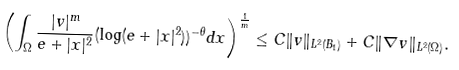<formula> <loc_0><loc_0><loc_500><loc_500>\left ( \int _ { \Omega } \frac { | v | ^ { m } } { e + | x | ^ { 2 } } ( \log ( e + | x | ^ { 2 } ) ) ^ { - \theta } d x \right ) ^ { \frac { 1 } { m } } \leq C \| v \| _ { L ^ { 2 } ( B _ { 1 } ) } + C \| \nabla v \| _ { L ^ { 2 } ( \Omega ) } .</formula> 